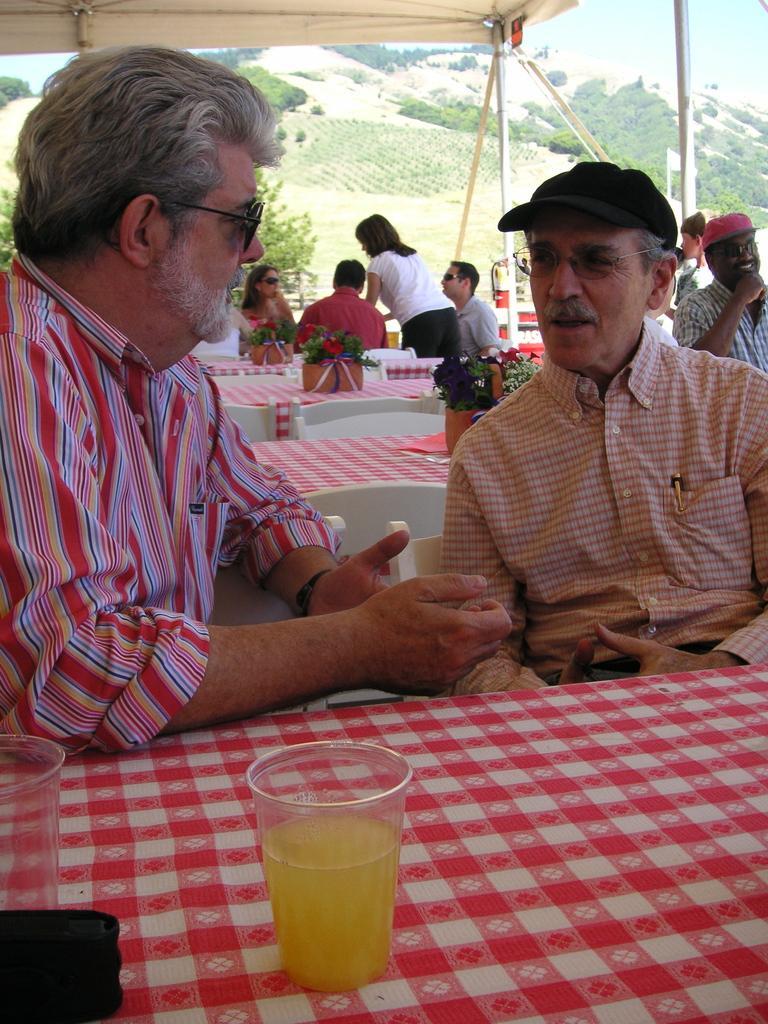How would you summarize this image in a sentence or two? In this image I can see the group people with different color dresses. I can see these people are sitting in-front of the table and one person is standing. On the tables I can see the flower pots and the glass can be soon on one of the table. These people are under the tent. In the background I can see many trees, mountains and the sky. 